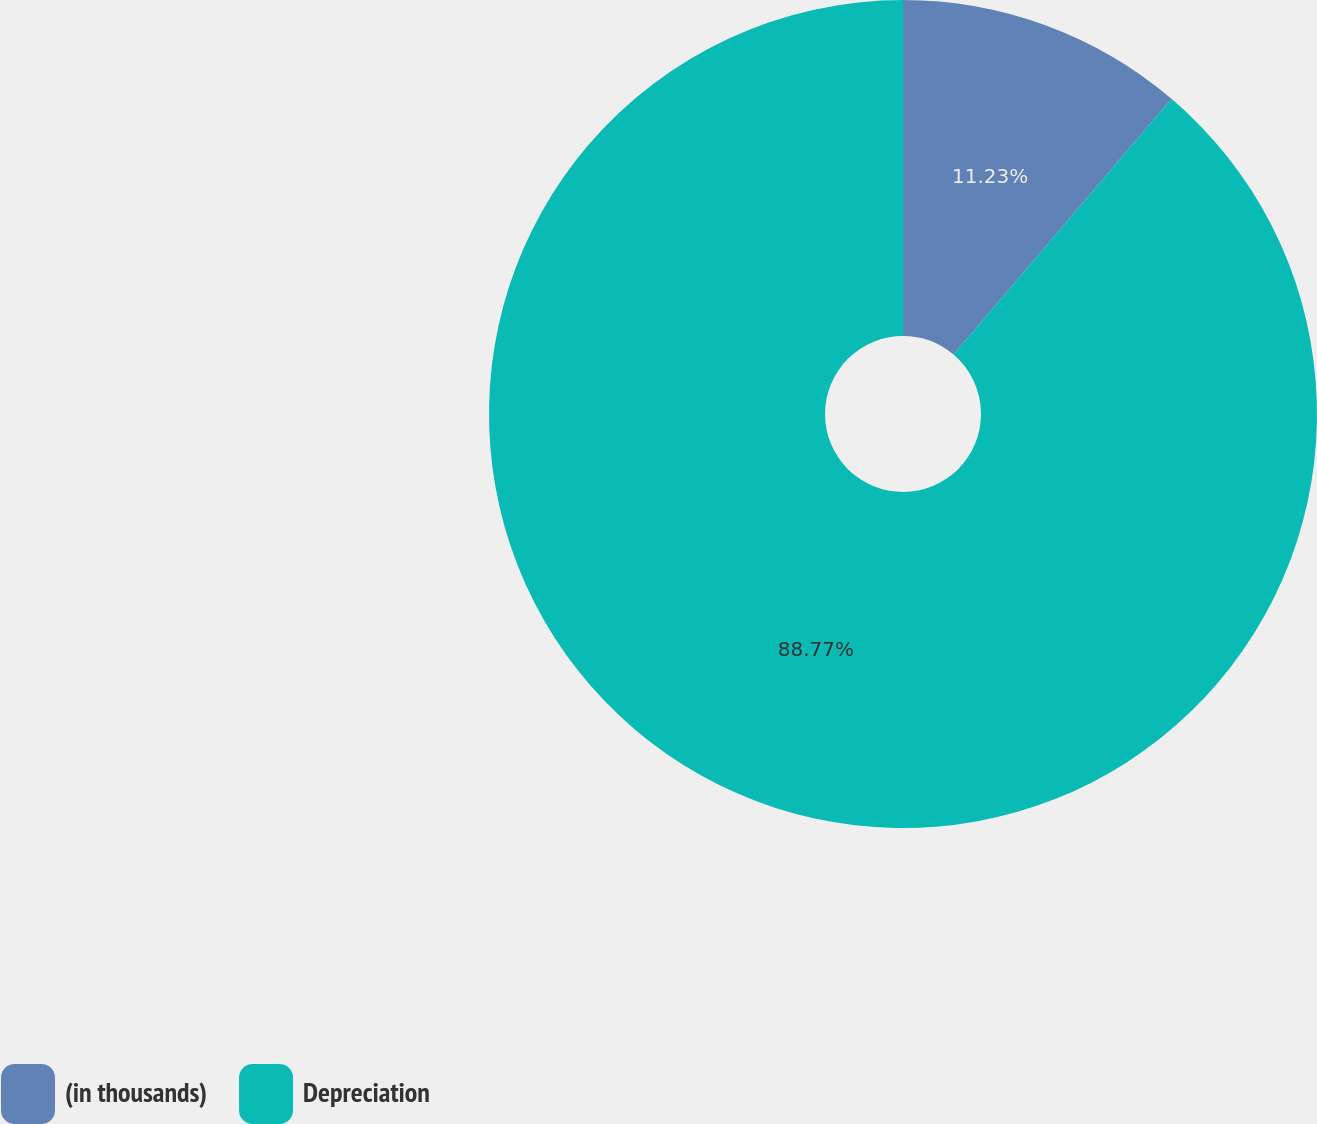Convert chart. <chart><loc_0><loc_0><loc_500><loc_500><pie_chart><fcel>(in thousands)<fcel>Depreciation<nl><fcel>11.23%<fcel>88.77%<nl></chart> 